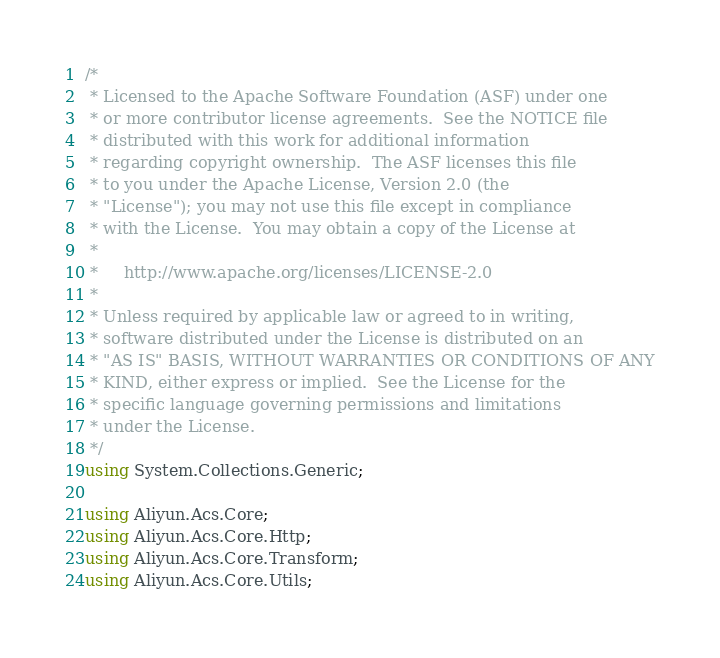Convert code to text. <code><loc_0><loc_0><loc_500><loc_500><_C#_>/*
 * Licensed to the Apache Software Foundation (ASF) under one
 * or more contributor license agreements.  See the NOTICE file
 * distributed with this work for additional information
 * regarding copyright ownership.  The ASF licenses this file
 * to you under the Apache License, Version 2.0 (the
 * "License"); you may not use this file except in compliance
 * with the License.  You may obtain a copy of the License at
 *
 *     http://www.apache.org/licenses/LICENSE-2.0
 *
 * Unless required by applicable law or agreed to in writing,
 * software distributed under the License is distributed on an
 * "AS IS" BASIS, WITHOUT WARRANTIES OR CONDITIONS OF ANY
 * KIND, either express or implied.  See the License for the
 * specific language governing permissions and limitations
 * under the License.
 */
using System.Collections.Generic;

using Aliyun.Acs.Core;
using Aliyun.Acs.Core.Http;
using Aliyun.Acs.Core.Transform;
using Aliyun.Acs.Core.Utils;</code> 